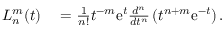<formula> <loc_0><loc_0><loc_500><loc_500>\begin{array} { r l } { L _ { n } ^ { m } ( t ) } & = \frac { 1 } { n ! } t ^ { - m } e ^ { t } \frac { d ^ { n } } { d t ^ { n } } \left ( t ^ { n + m } e ^ { - t } \right ) . } \end{array}</formula> 